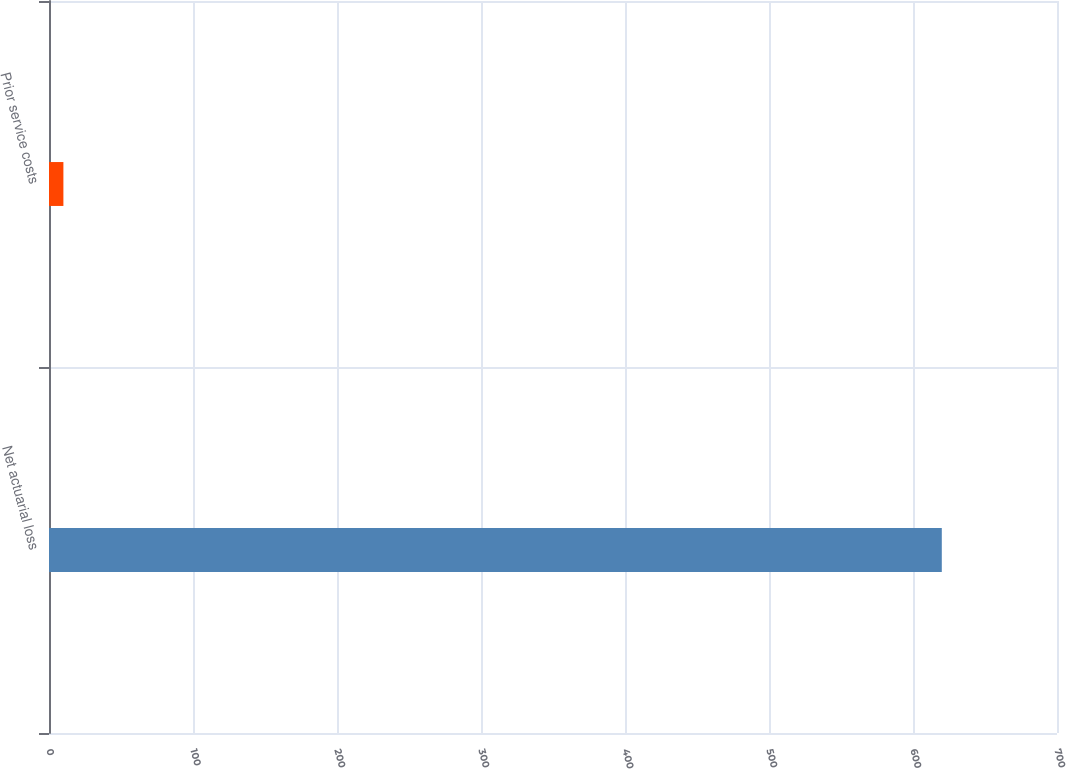Convert chart. <chart><loc_0><loc_0><loc_500><loc_500><bar_chart><fcel>Net actuarial loss<fcel>Prior service costs<nl><fcel>620<fcel>10<nl></chart> 